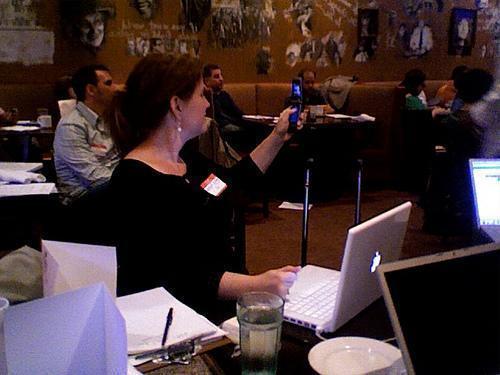How many laptops are there?
Give a very brief answer. 3. How many people are visible?
Give a very brief answer. 4. How many dining tables can be seen?
Give a very brief answer. 2. 